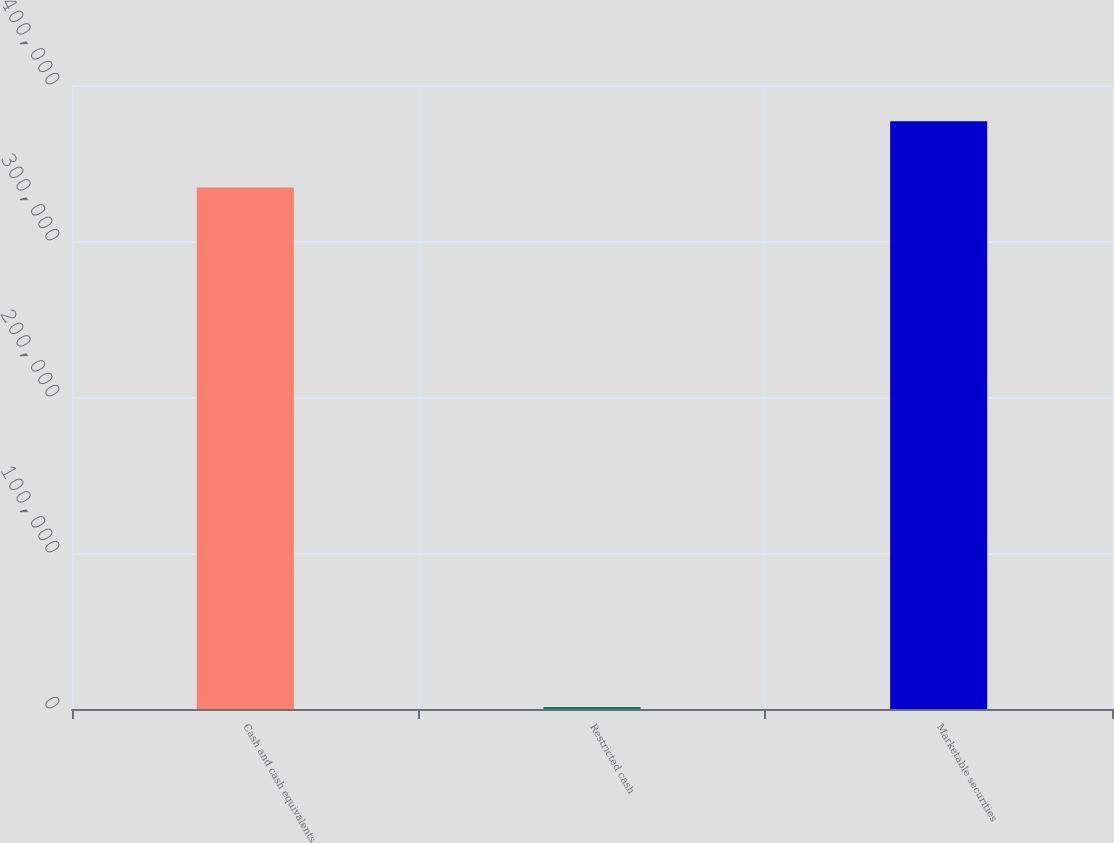<chart> <loc_0><loc_0><loc_500><loc_500><bar_chart><fcel>Cash and cash equivalents<fcel>Restricted cash<fcel>Marketable securities<nl><fcel>334352<fcel>1356<fcel>376723<nl></chart> 